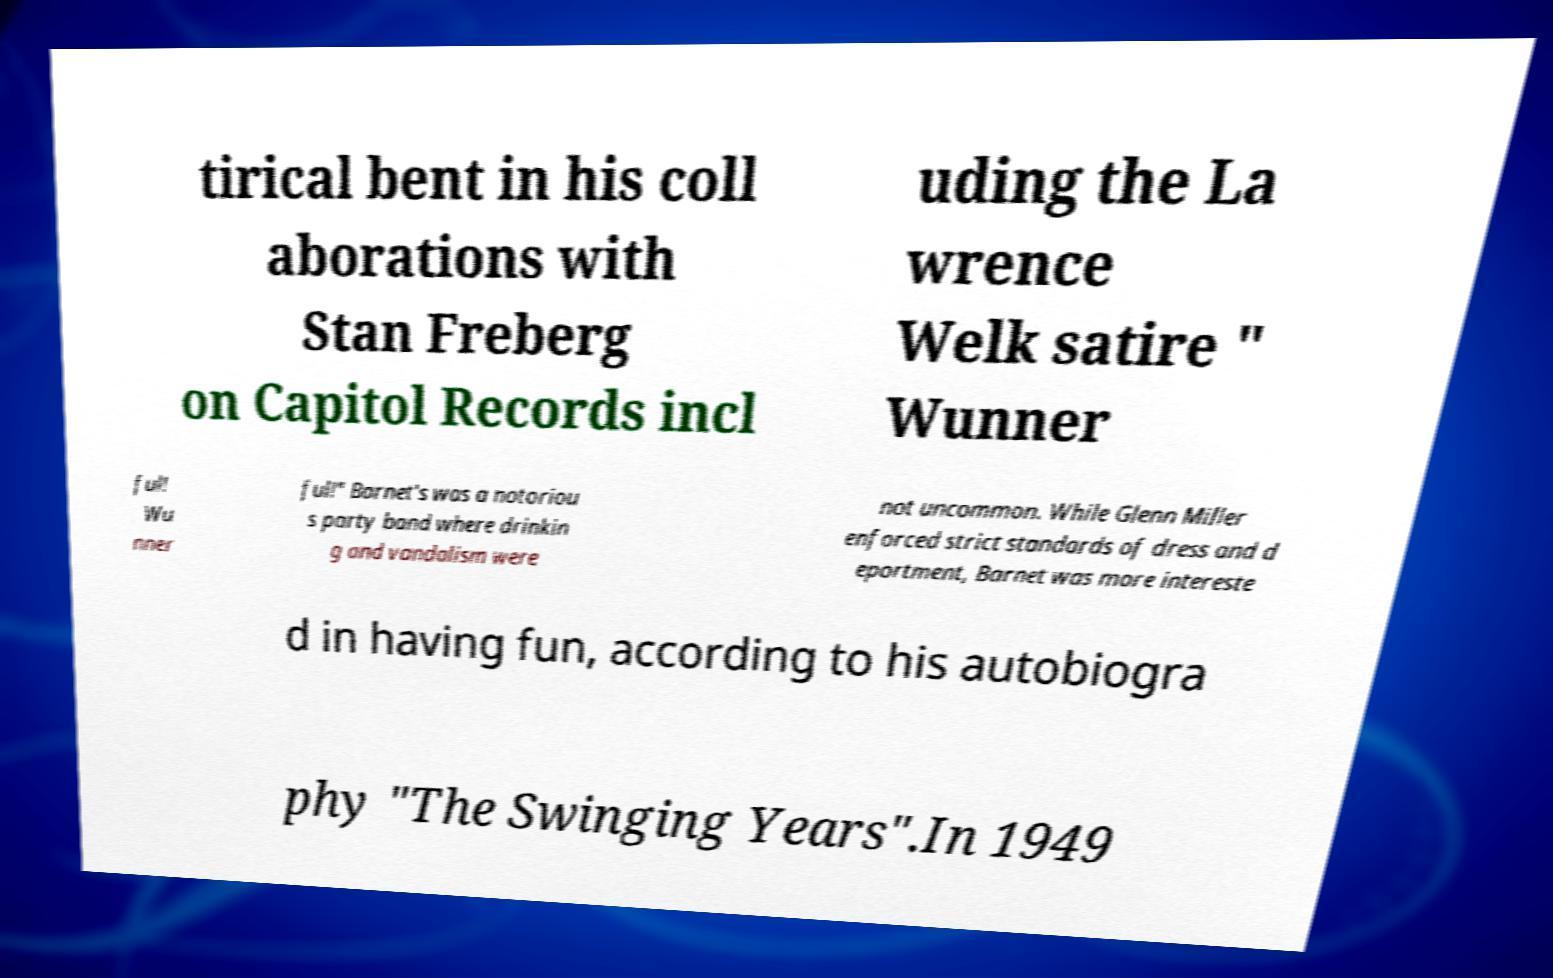Could you extract and type out the text from this image? tirical bent in his coll aborations with Stan Freberg on Capitol Records incl uding the La wrence Welk satire " Wunner ful! Wu nner ful!" Barnet's was a notoriou s party band where drinkin g and vandalism were not uncommon. While Glenn Miller enforced strict standards of dress and d eportment, Barnet was more intereste d in having fun, according to his autobiogra phy "The Swinging Years".In 1949 